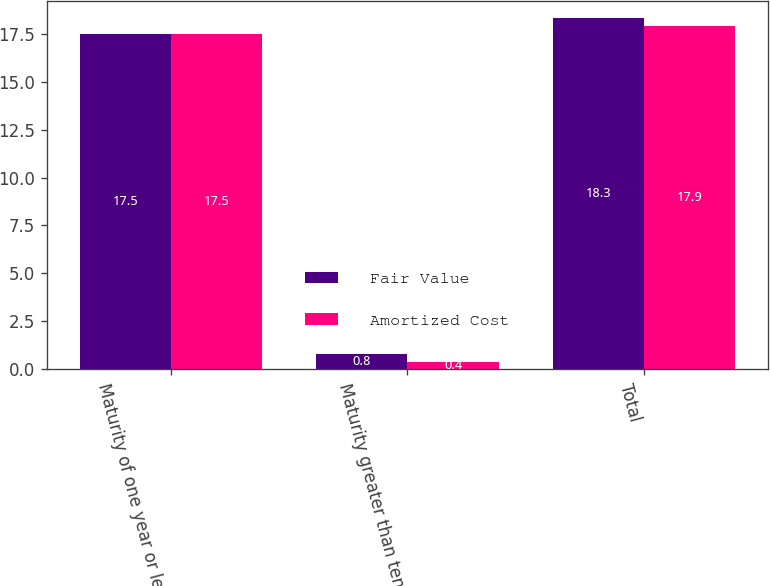Convert chart to OTSL. <chart><loc_0><loc_0><loc_500><loc_500><stacked_bar_chart><ecel><fcel>Maturity of one year or less<fcel>Maturity greater than ten<fcel>Total<nl><fcel>Fair Value<fcel>17.5<fcel>0.8<fcel>18.3<nl><fcel>Amortized Cost<fcel>17.5<fcel>0.4<fcel>17.9<nl></chart> 